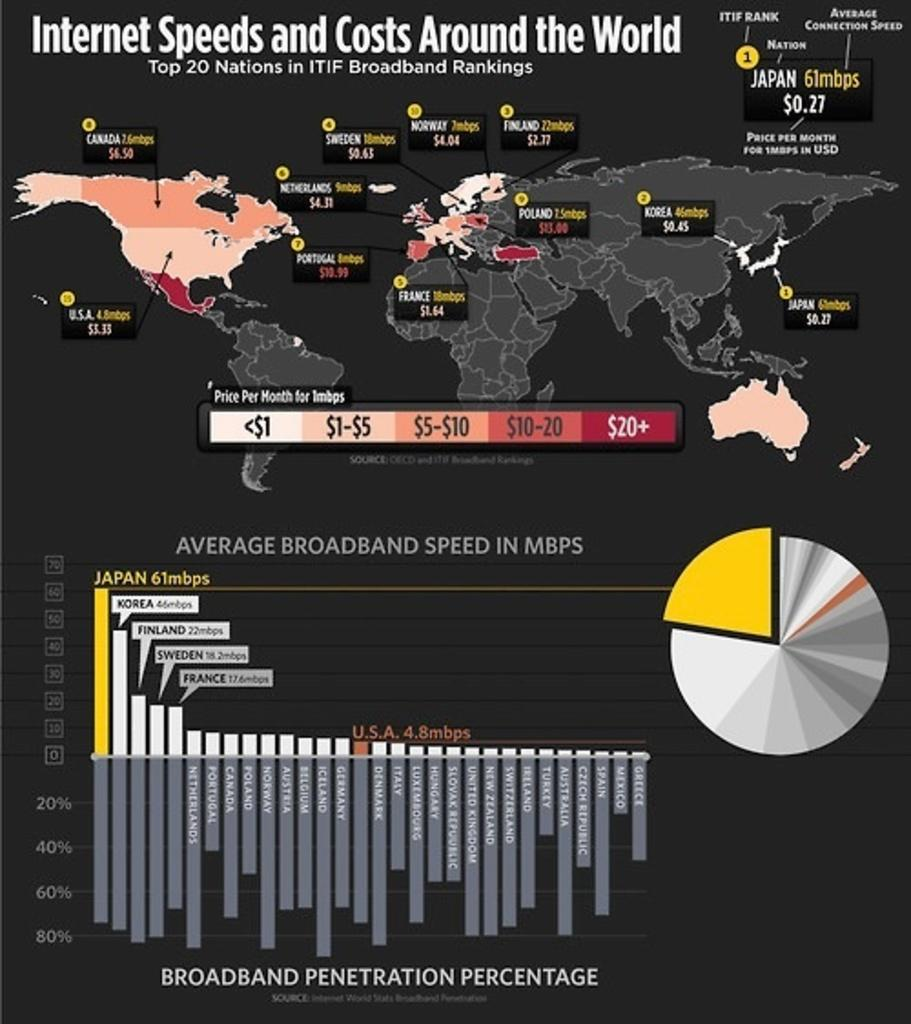<image>
Render a clear and concise summary of the photo. A chart shows different internet speeds and costs around the world. 